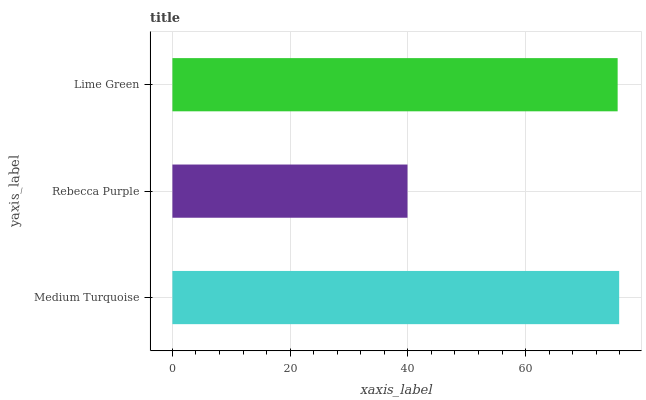Is Rebecca Purple the minimum?
Answer yes or no. Yes. Is Medium Turquoise the maximum?
Answer yes or no. Yes. Is Lime Green the minimum?
Answer yes or no. No. Is Lime Green the maximum?
Answer yes or no. No. Is Lime Green greater than Rebecca Purple?
Answer yes or no. Yes. Is Rebecca Purple less than Lime Green?
Answer yes or no. Yes. Is Rebecca Purple greater than Lime Green?
Answer yes or no. No. Is Lime Green less than Rebecca Purple?
Answer yes or no. No. Is Lime Green the high median?
Answer yes or no. Yes. Is Lime Green the low median?
Answer yes or no. Yes. Is Medium Turquoise the high median?
Answer yes or no. No. Is Medium Turquoise the low median?
Answer yes or no. No. 